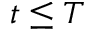<formula> <loc_0><loc_0><loc_500><loc_500>t \leq T</formula> 